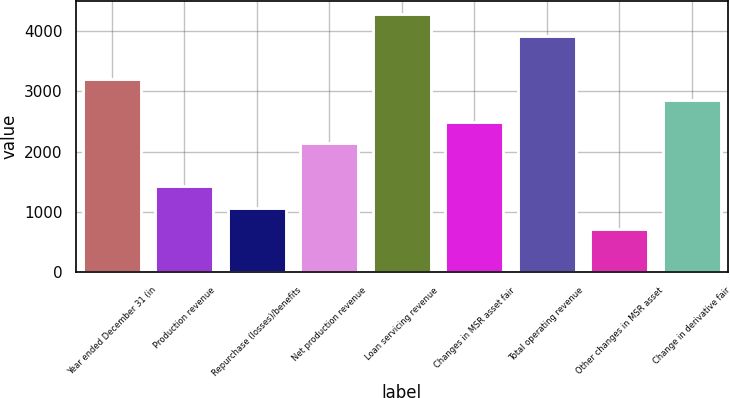Convert chart. <chart><loc_0><loc_0><loc_500><loc_500><bar_chart><fcel>Year ended December 31 (in<fcel>Production revenue<fcel>Repurchase (losses)/benefits<fcel>Net production revenue<fcel>Loan servicing revenue<fcel>Changes in MSR asset fair<fcel>Total operating revenue<fcel>Other changes in MSR asset<fcel>Change in derivative fair<nl><fcel>3207<fcel>1427<fcel>1071<fcel>2139<fcel>4275<fcel>2495<fcel>3919<fcel>715<fcel>2851<nl></chart> 